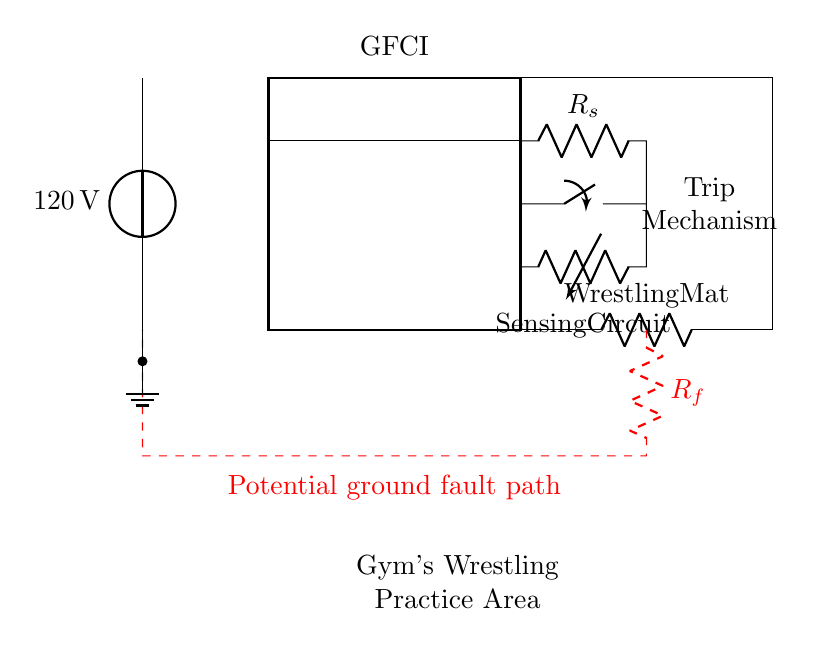What is the voltage of the power source? The voltage is specified as 120 volts, which is directly indicated next to the power source in the circuit.
Answer: 120 volts What component protects against ground faults? The component that protects against ground faults is the Ground Fault Circuit Interrupter, clearly labeled as GFCI in the diagram.
Answer: GFCI What is the load in this circuit? The load in this circuit is labeled as Wrestling Mat, which indicates the device that consumes power from the circuit.
Answer: Wrestling Mat What does the red dashed line represent? The red dashed line indicates the potential ground fault path, showing the alternative route for current in case of a fault.
Answer: Potential ground fault path How many switches are present in this circuit? There is one switch present in the circuit, indicated next to the trip mechanism in the diagram.
Answer: One What is the function of the trip mechanism? The trip mechanism serves to interrupt the circuit when a ground fault is detected by the sensing circuit, ensuring safety.
Answer: Interrupt circuit What does the ground symbol signify in this circuit? The ground symbol signifies the reference point of zero voltage in the circuit, which is also used to safely discharge any fault currents.
Answer: Zero voltage reference 